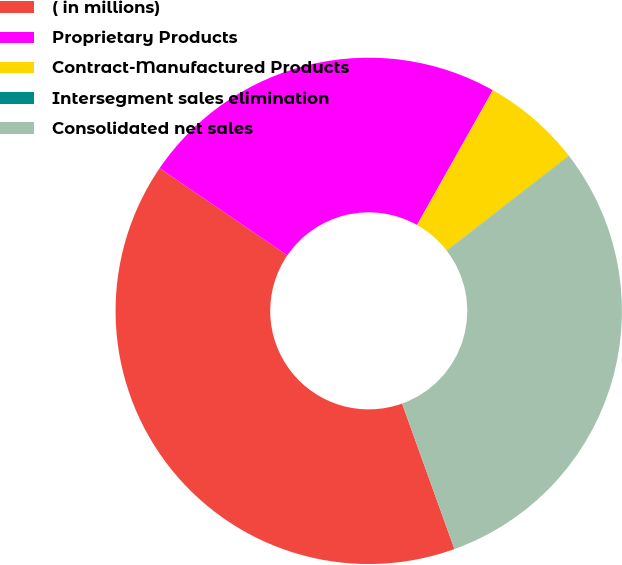Convert chart to OTSL. <chart><loc_0><loc_0><loc_500><loc_500><pie_chart><fcel>( in millions)<fcel>Proprietary Products<fcel>Contract-Manufactured Products<fcel>Intersegment sales elimination<fcel>Consolidated net sales<nl><fcel>40.03%<fcel>23.63%<fcel>6.36%<fcel>0.02%<fcel>29.97%<nl></chart> 